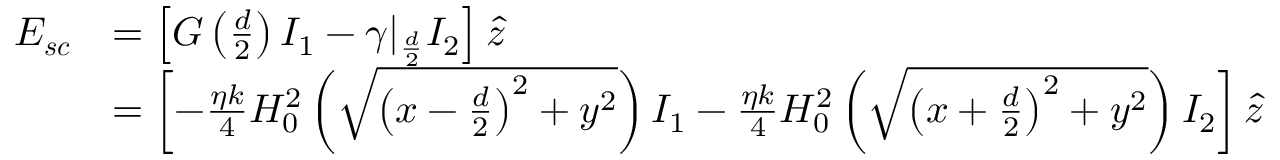Convert formula to latex. <formula><loc_0><loc_0><loc_500><loc_500>\begin{array} { r l } { E _ { s c } } & { = \left [ G \left ( \frac { d } { 2 } \right ) I _ { 1 } - \gamma | _ { \frac { d } { 2 } } I _ { 2 } \right ] \hat { z } } \\ & { = \left [ - \frac { \eta k } { 4 } H _ { 0 } ^ { 2 } \left ( \sqrt { \left ( x - \frac { d } { 2 } \right ) ^ { 2 } + y ^ { 2 } } \right ) I _ { 1 } - \frac { \eta k } { 4 } H _ { 0 } ^ { 2 } \left ( \sqrt { \left ( x + \frac { d } { 2 } \right ) ^ { 2 } + y ^ { 2 } } \right ) I _ { 2 } \right ] \hat { z } } \end{array}</formula> 